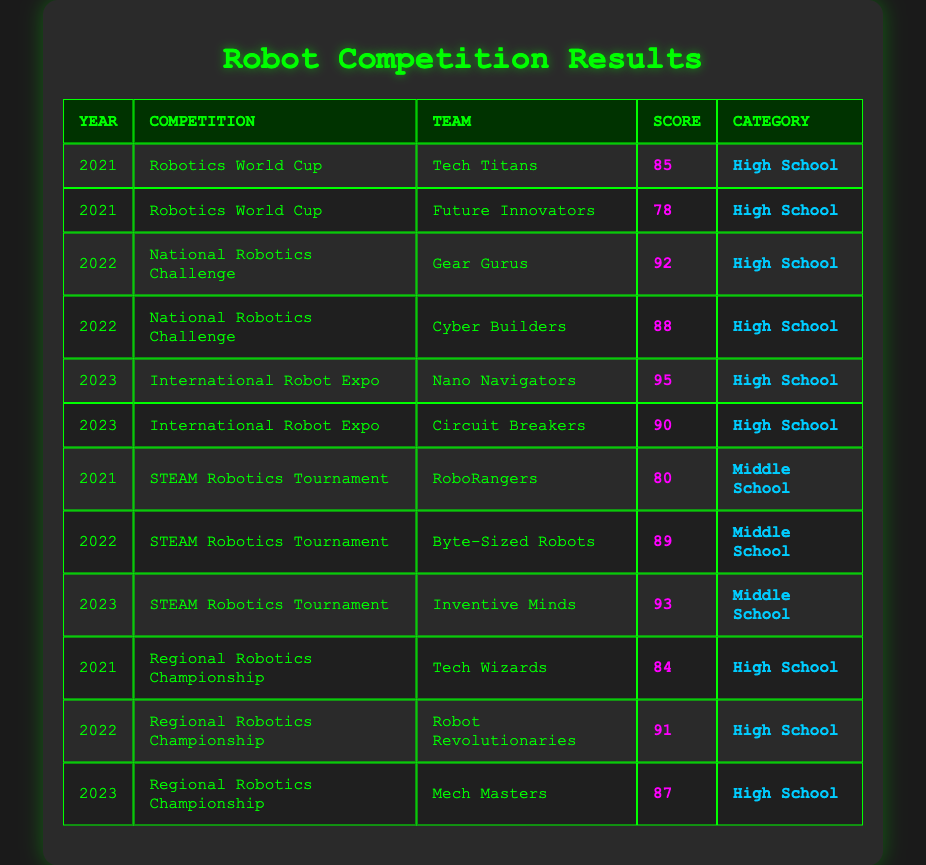What team scored the highest in the 2023 International Robot Expo? The only teams that participated in the 2023 International Robot Expo are Nano Navigators and Circuit Breakers, with scores of 95 and 90 respectively. Therefore, the highest scoring team is Nano Navigators.
Answer: Nano Navigators How many teams participated in the 2022 STEAM Robotics Tournament? There is only one entry for the 2022 STEAM Robotics Tournament, which is Byte-Sized Robots. Therefore, only one team participated in that tournament.
Answer: 1 What was the average score for High School teams in 2021? The High School teams with scores from 2021 are Tech Titans (85), Future Innovators (78), and Tech Wizards (84). Adding these scores gives 85 + 78 + 84 = 247. Dividing by 3 (the number of teams) gives an average of 247 / 3 ≈ 82.33.
Answer: 82.33 Did any team win a competition with a score below 80? The lowest recorded score is 78 from the Future Innovators in the 2021 Robotics World Cup, which is below 80. Thus, there was at least one team that won with a score below 80.
Answer: Yes Which competition had the highest scoring team in 2022? In 2022, the National Robotics Challenge had Gear Gurus with a score of 92, while the Regional Robotics Championship had Robot Revolutionaries with a score of 91. Comparing these, the National Robotics Challenge had the highest scoring team.
Answer: National Robotics Challenge How many teams scored above 90 in the 2023 competitions? The teams that scored above 90 in 2023 are Nano Navigators (95) and Circuit Breakers (90 in International Robot Expo), and Inventive Minds (93 in STEAM Robotics Tournament). There are three teams scoring above 90 when including exact scores as well.
Answer: 3 Which category had the highest average score in 2023? In 2023, the High School scores were 95 (Nano Navigators), 90 (Circuit Breakers), and the Middle School score was 93 (Inventive Minds). The average for High School is (95 + 90) / 2 = 92.5, and for Middle School it is 93 / 1 = 93. Thus, the Middle School category had the highest average score.
Answer: Middle School Who was the second highest scoring team in 2022? The highest scoring team in 2022 was Gear Gurus (92), followed by Robot Revolutionaries (91). By identifying these scores in descending order, we can determine the second highest scoring team is Robot Revolutionaries.
Answer: Robot Revolutionaries What was the total number of competitions listed in the table? The competitions listed are Robotics World Cup (2 entries), National Robotics Challenge (2 entries), International Robot Expo (2 entries), STEAM Robotics Tournament (3 entries), and Regional Robotics Championship (3 entries). Adding these gives a total of 2 + 2 + 2 + 3 + 3 = 12 instances of competitions, but only 5 distinct events.
Answer: 5 distinct competitions Which team had the lowest score in the table? The team with the lowest score is Future Innovators with a score of 78 in the Robotics World Cup in 2021. This is the only score below 80 in the table.
Answer: Future Innovators 